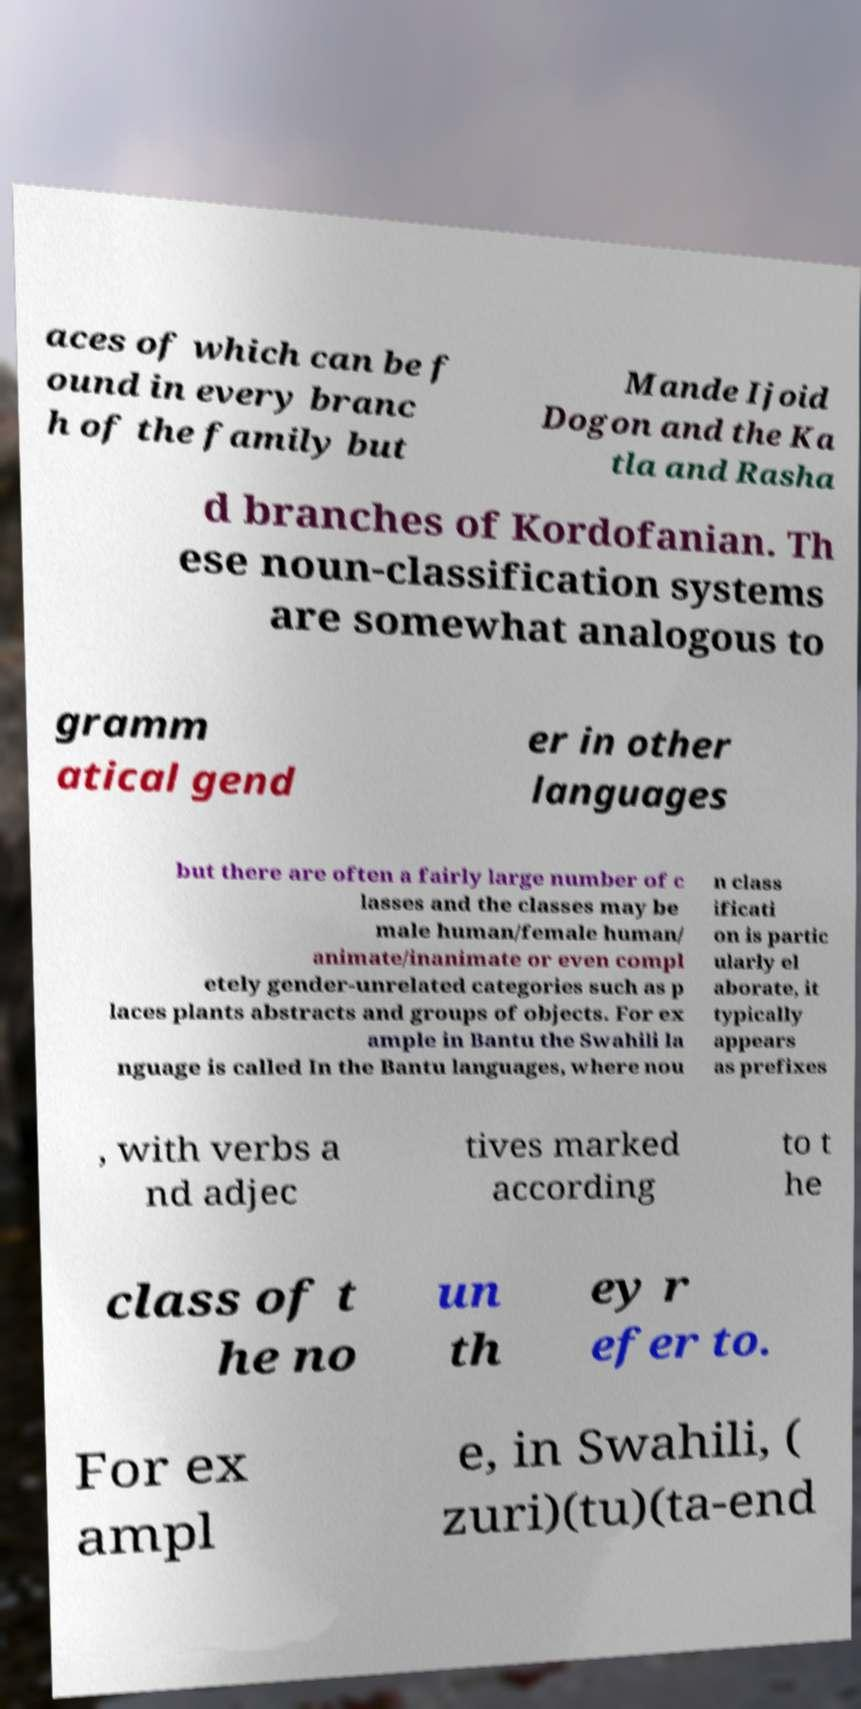Could you assist in decoding the text presented in this image and type it out clearly? aces of which can be f ound in every branc h of the family but Mande Ijoid Dogon and the Ka tla and Rasha d branches of Kordofanian. Th ese noun-classification systems are somewhat analogous to gramm atical gend er in other languages but there are often a fairly large number of c lasses and the classes may be male human/female human/ animate/inanimate or even compl etely gender-unrelated categories such as p laces plants abstracts and groups of objects. For ex ample in Bantu the Swahili la nguage is called In the Bantu languages, where nou n class ificati on is partic ularly el aborate, it typically appears as prefixes , with verbs a nd adjec tives marked according to t he class of t he no un th ey r efer to. For ex ampl e, in Swahili, ( zuri)(tu)(ta-end 